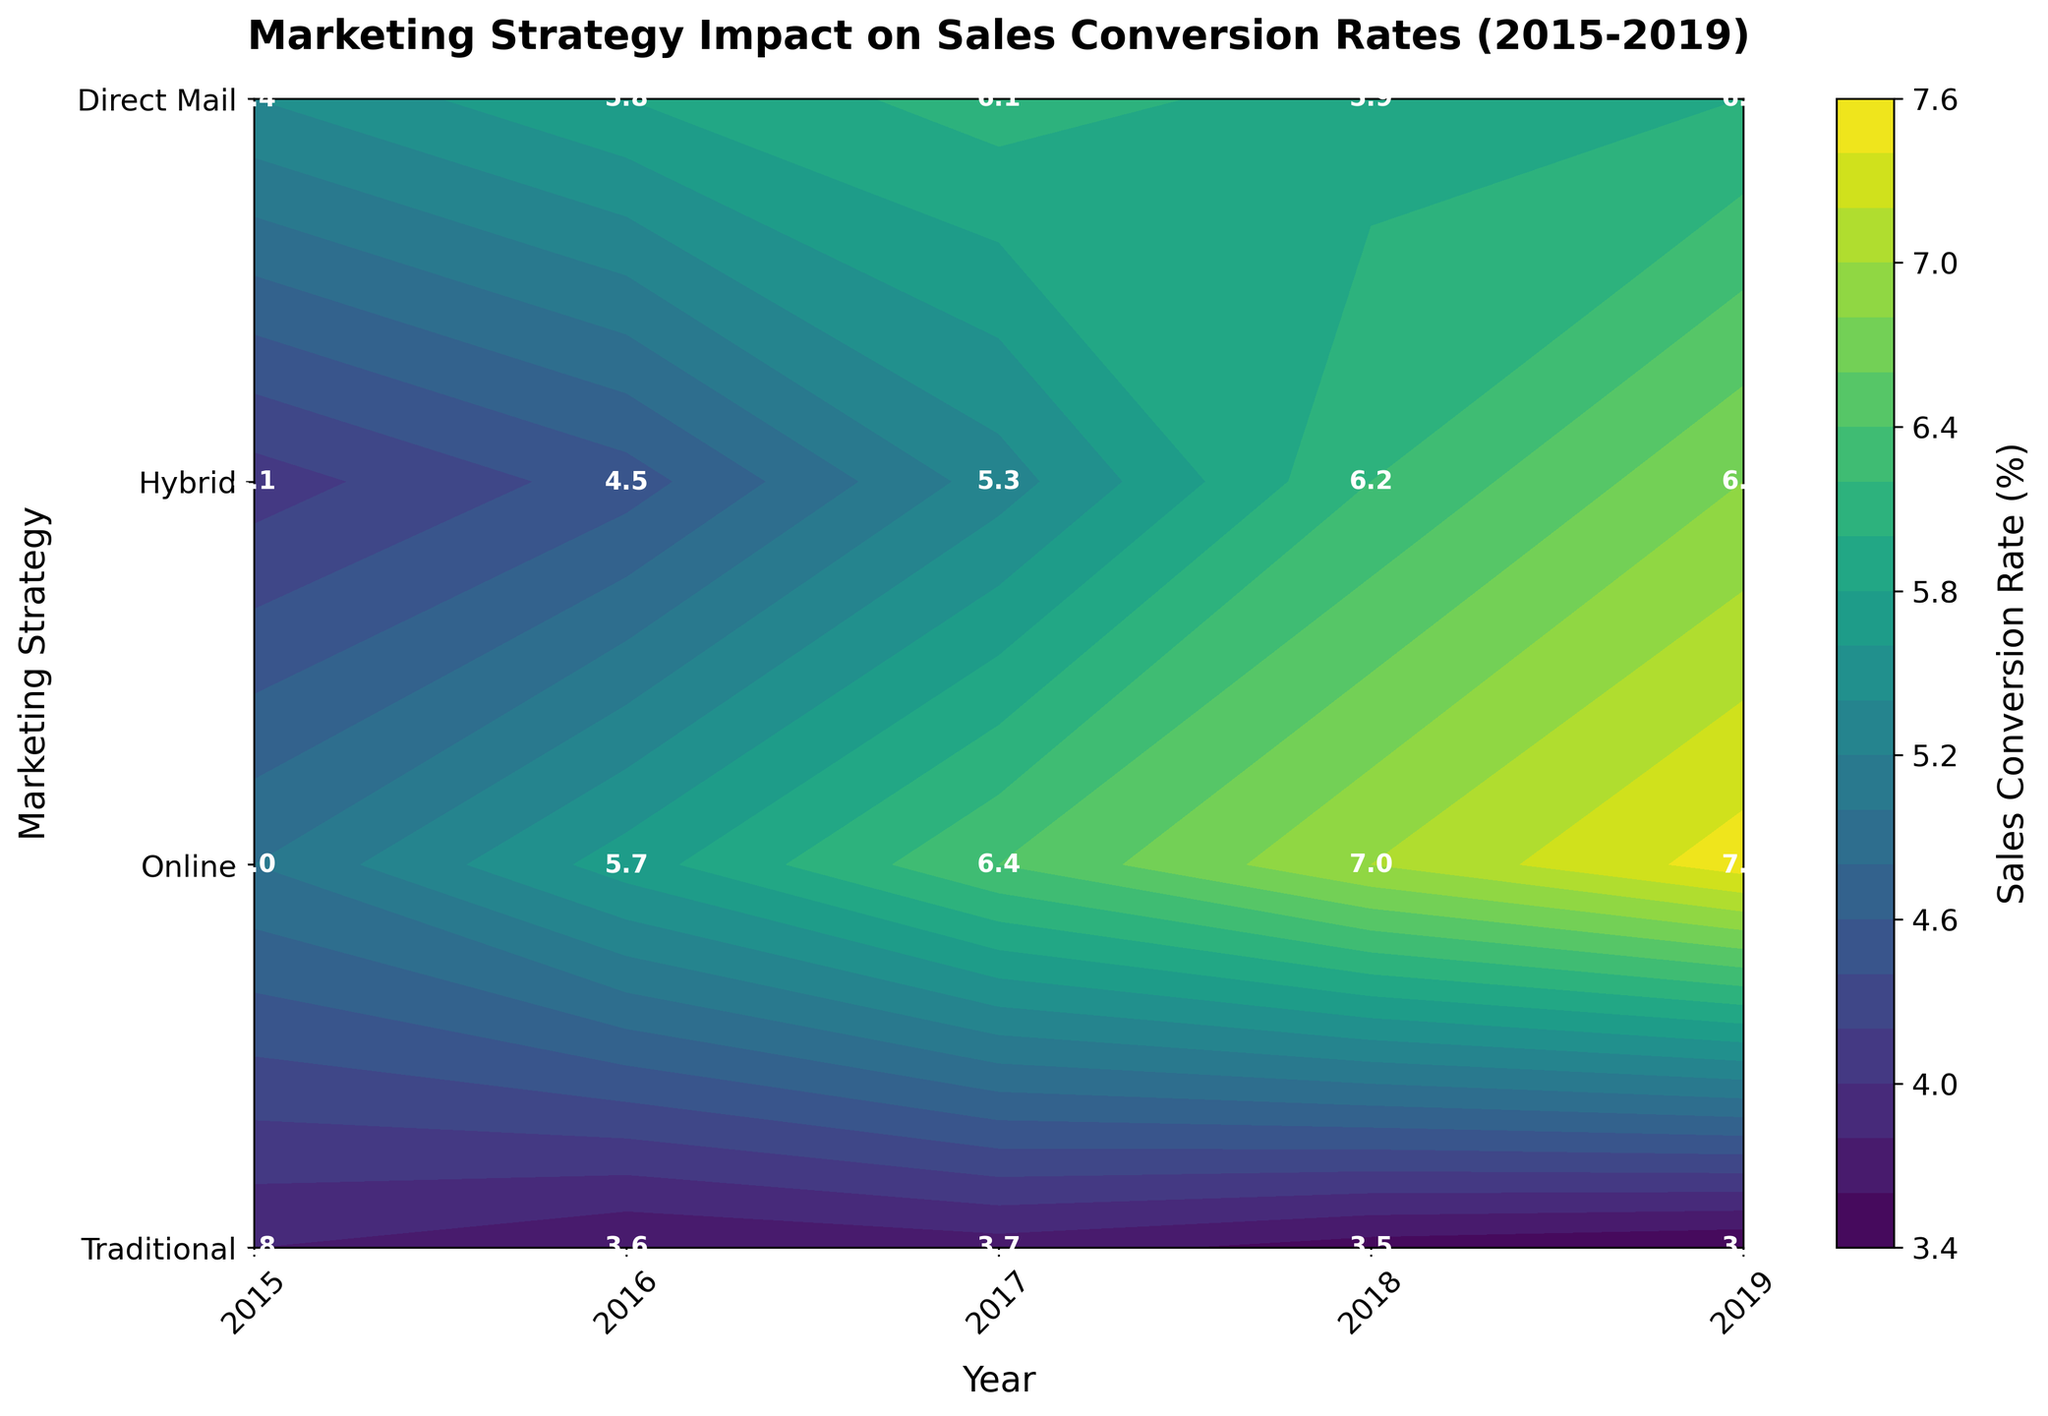What is the title of the plot? The title of the plot is displayed at the top and provides a concise summary of the data being presented. In this case, it describes the plot as "Marketing Strategy Impact on Sales Conversion Rates (2015-2019)".
Answer: Marketing Strategy Impact on Sales Conversion Rates (2015-2019) What are the axes labels? The axes labels are textual descriptions of what each axis represents. The x-axis is labeled "Year," and the y-axis is labeled "Marketing Strategy."
Answer: Year, Marketing Strategy Which marketing strategy had the highest sales conversion rate in 2019? By examining the figure and looking at the row corresponding to 2019 and finding the highest value, we can see that the “Hybrid” strategy had the highest sales conversion rate in 2019, with a rate of 7.5%.
Answer: Hybrid What color predominates the highest sales conversion rate regions in the contour plot? The contour color map is used to visually distinguish sales conversion rates. The highest values are shown in bright yellow or light green, which are present in the upper conversion rate regions.
Answer: Bright yellow or light green What's the average sales conversion rate for the "Traditional" strategy from 2015 to 2019? The sales conversion rates for the Traditional strategy from 2015 to 2019 are 5.4, 5.8, 6.1, 5.9, and 6.0. Adding these rates gives 29.2, and dividing by the 5 years gives us the average: 29.2 / 5 = 5.84.
Answer: 5.84 Between the "Online" and "Direct Mail" strategies, which showed a greater increase in sales conversion rates from 2015 to 2019? The "Online" strategy's conversion rate increased from 4.1 in 2015 to 6.8 in 2019, which is an increase of 2.7. The "Direct Mail" strategy's conversion rate decreased from 3.8 in 2015 to 3.4 in 2019, showing a decrease of 0.4. Thus, "Online" showed a greater increase.
Answer: Online What is the trend of the "Hybrid" strategy's sales conversion rate over the years? By looking at each year's corresponding rate for the Hybrid strategy, we see it increases consistently from 5.0 in 2015 to 7.5 in 2019, indicating a steady upward trend.
Answer: Upward trend In which year did the "Online" strategy surpass the "Traditional" strategy in terms of sales conversion rate? Comparing the conversion rates for both strategies year by year, the "Online" strategy had a higher rate than the "Traditional" strategy starting in 2018 (6.2 vs 5.9).
Answer: 2018 